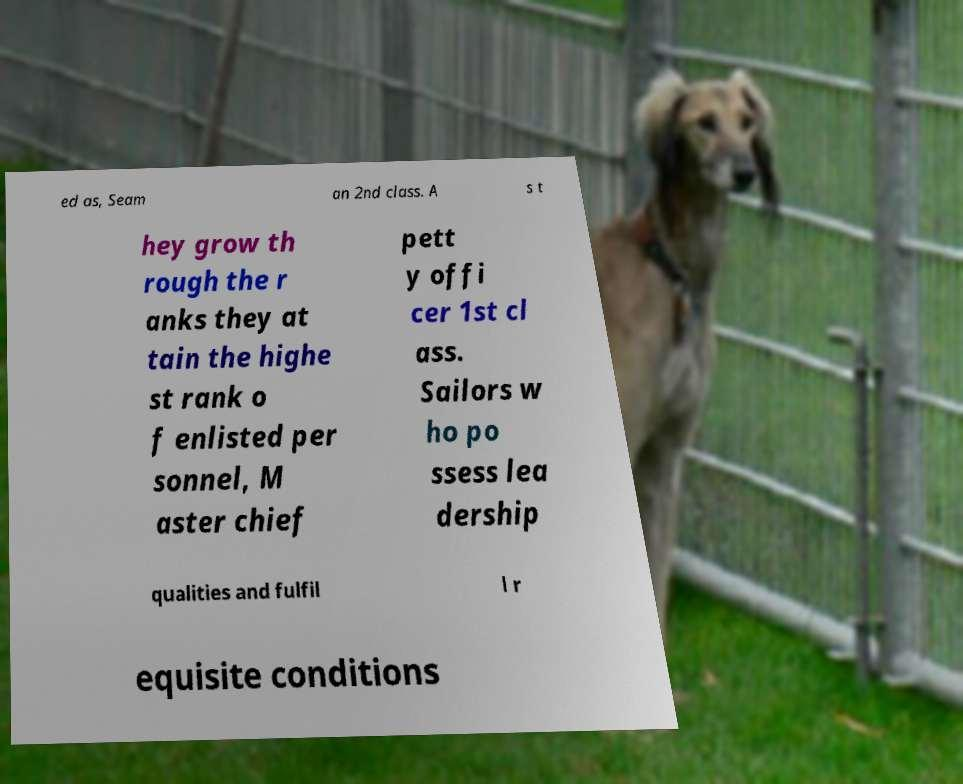For documentation purposes, I need the text within this image transcribed. Could you provide that? ed as, Seam an 2nd class. A s t hey grow th rough the r anks they at tain the highe st rank o f enlisted per sonnel, M aster chief pett y offi cer 1st cl ass. Sailors w ho po ssess lea dership qualities and fulfil l r equisite conditions 